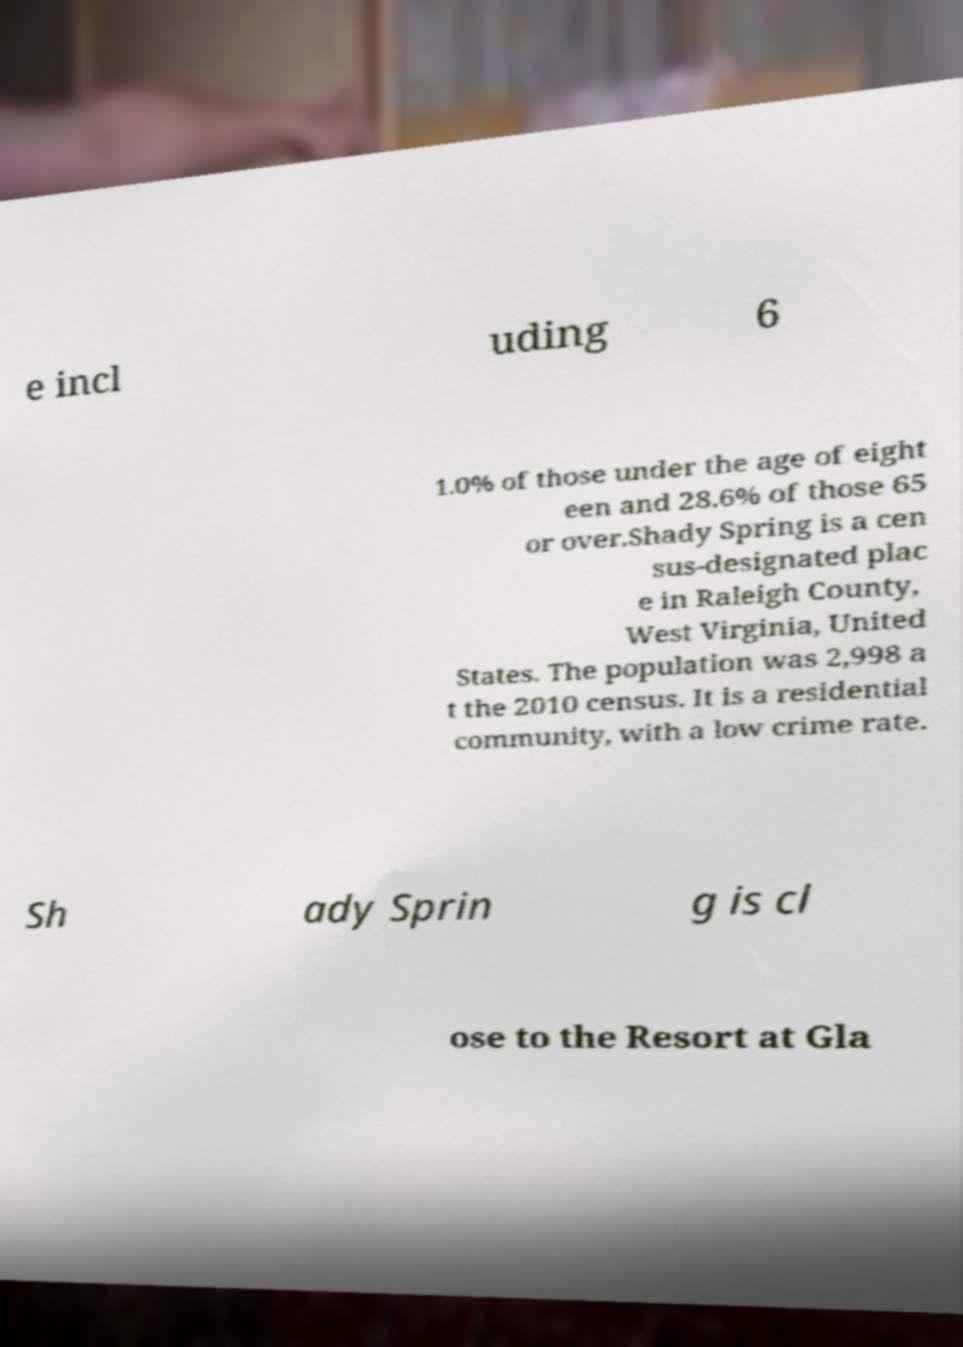I need the written content from this picture converted into text. Can you do that? e incl uding 6 1.0% of those under the age of eight een and 28.6% of those 65 or over.Shady Spring is a cen sus-designated plac e in Raleigh County, West Virginia, United States. The population was 2,998 a t the 2010 census. It is a residential community, with a low crime rate. Sh ady Sprin g is cl ose to the Resort at Gla 